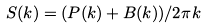Convert formula to latex. <formula><loc_0><loc_0><loc_500><loc_500>S ( k ) = ( P ( k ) + B ( k ) ) / 2 \pi k</formula> 